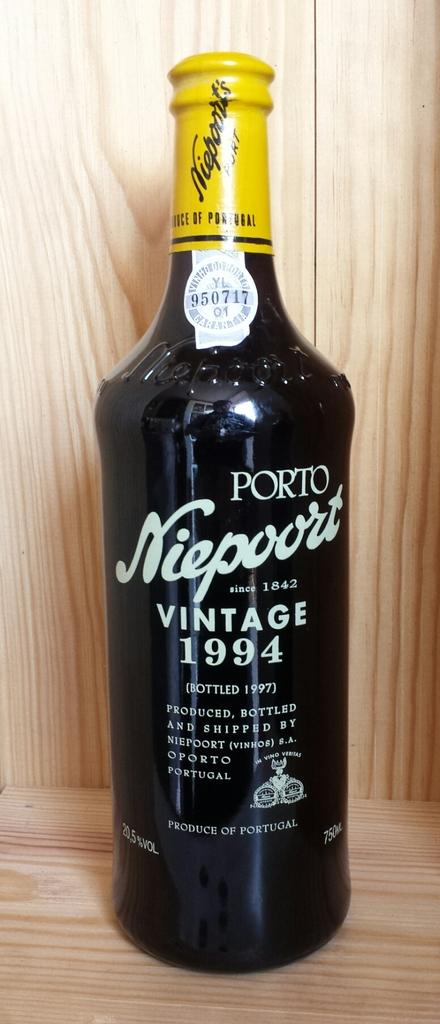<image>
Share a concise interpretation of the image provided. A bottle of alcohol made by porto niepoort says vintage 1994 on it 